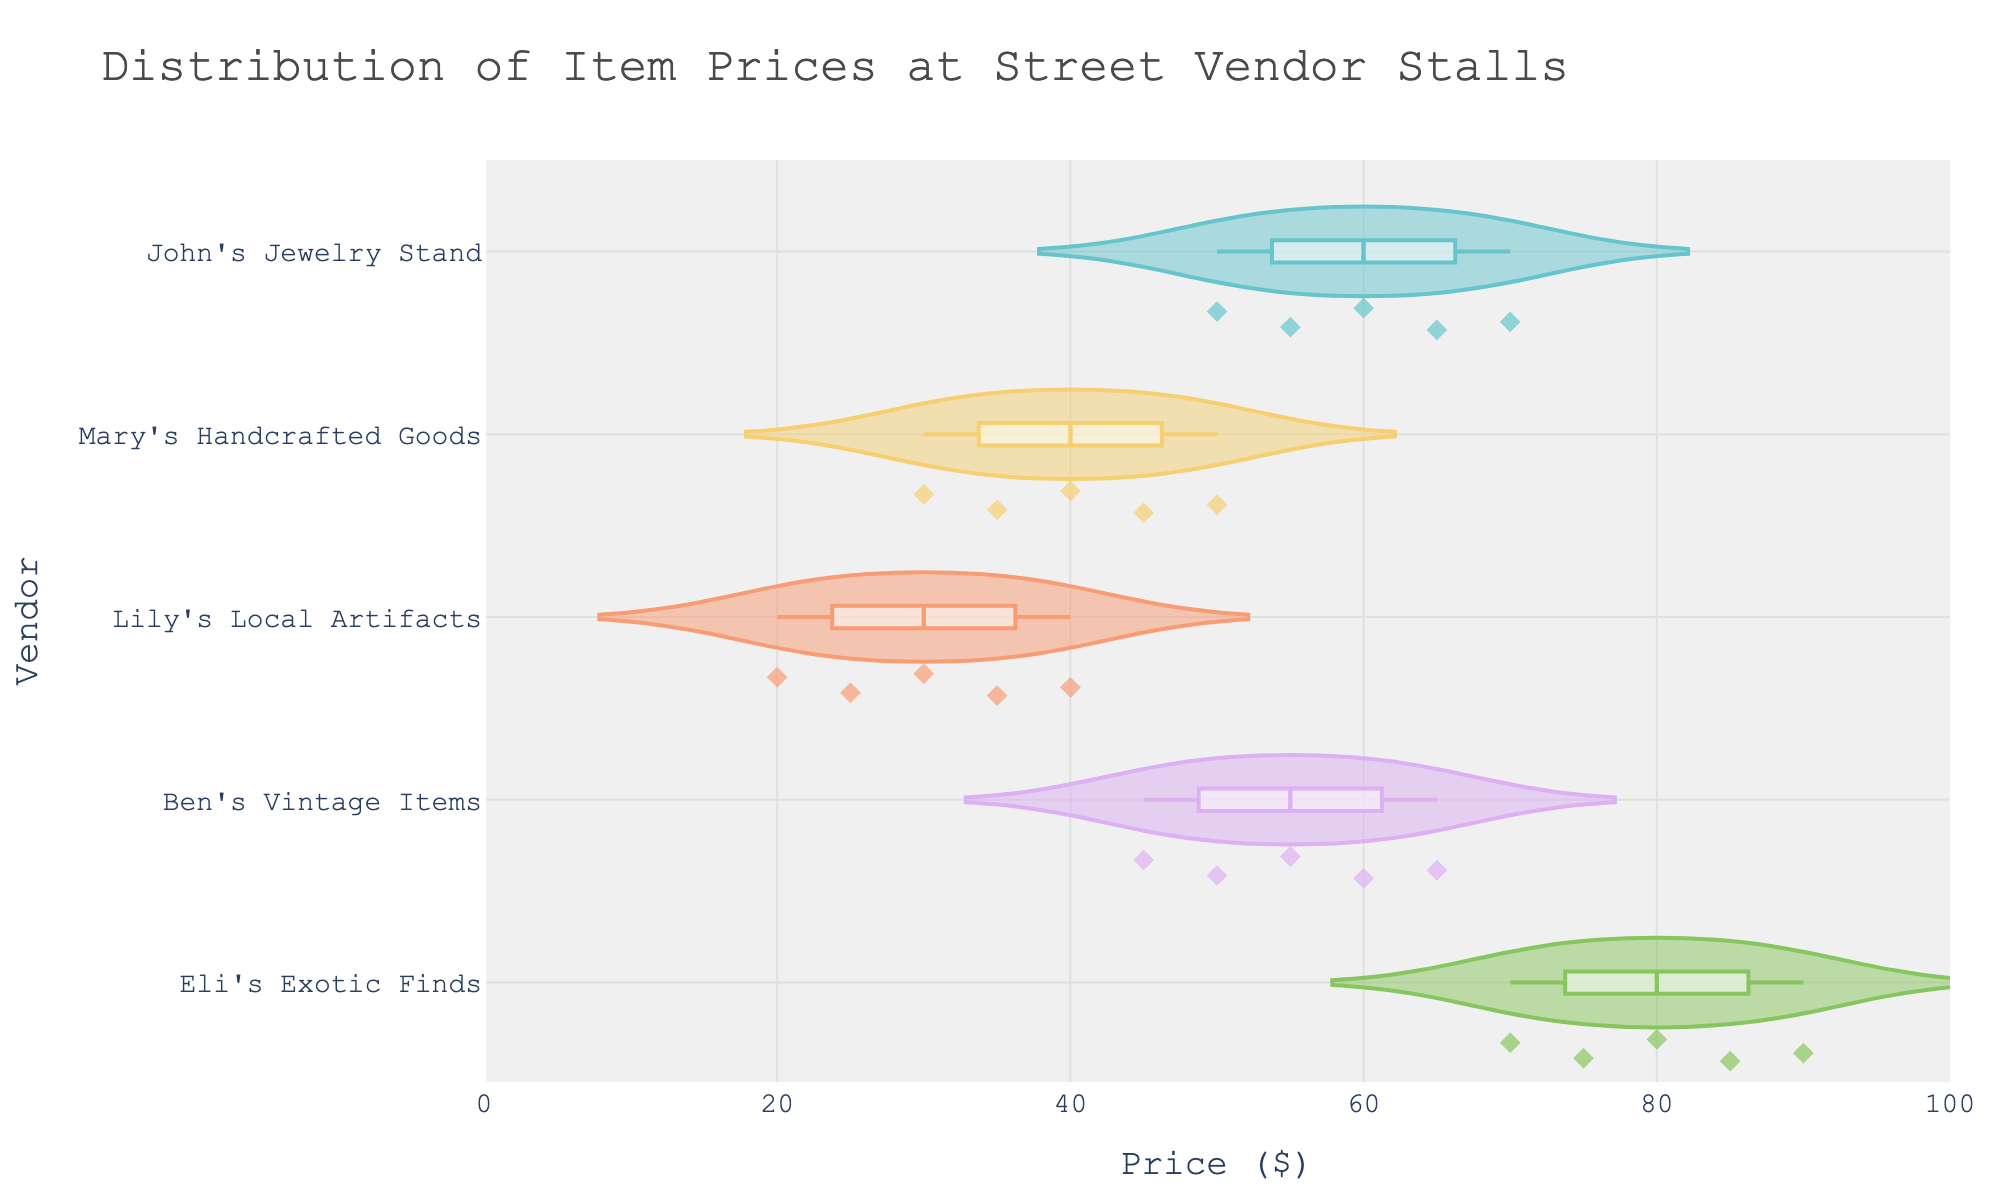What's the title of the figure? The title of the figure is located at the top and reads "Distribution of Item Prices at Street Vendor Stalls"
Answer: Distribution of Item Prices at Street Vendor Stalls Which street vendor stall has the highest price? Looking at the horizontal violin plots, Eli's Exotic Finds reaches the furthest to the right on the x-axis, indicating the highest prices.
Answer: Eli's Exotic Finds What's the range of prices for John's Jewelry Stand? Observing the width of the violin plot for John's Jewelry Stand along the x-axis, the prices range from $50 to $70.
Answer: $50 to $70 Which vendor has the widest distribution of prices? Comparing the width of the violin plots for each vendor along the x-axis, Ben's Vintage Items and John's Jewelry Stand both display wide distributions, but Eli's Exotic Finds spans from $70 to $90, indicating the widest price range.
Answer: Eli's Exotic Finds Do any vendors have overlapping price ranges? By examining the overlapping areas of the violin plots, we see that there are overlapping price ranges between Ben's Vintage Items and John's Jewelry Stand around $50 to $65.
Answer: Yes, Ben's Vintage Items and John's Jewelry Stand What is the median price of items at Mary's Handcrafted Goods? The median line in the box plot within Mary's Handcrafted Goods' violin plot is around $40.
Answer: $40 Which vendor's items have the lowest median price? Observing the median lines in the box plots, Lily's Local Artifacts has the lowest median price located at around $30.
Answer: Lily's Local Artifacts How do the distributions of prices for John's Jewelry Stand and Eli's Exotic Finds compare? Comparing the violin plots for John's Jewelry Stand and Eli's Exotic Finds, the former has prices clustered around the $50-$70 range, while the latter spans a higher range from $70 to $90, indicating higher prices for Eli's Exotic Finds.
Answer: Eli's Exotic Finds has higher prices than John's Jewelry Stand What's the interquartile range (IQR) of prices at Ben's Vintage Items? The interquartile range (IQR) is the range within the box of the violin plot. For Ben's Vintage Items, the IQR spans from around $50 to $60.
Answer: $10 Which vendor has the most concentrated price points? The concentration of price points can be seen where the violins are thickest. Lily's Local Artifacts and Mary’s Handcrafted Goods show more concentrated price distributions compared to others.
Answer: Lily's Local Artifacts and Mary’s Handcrafted Goods 